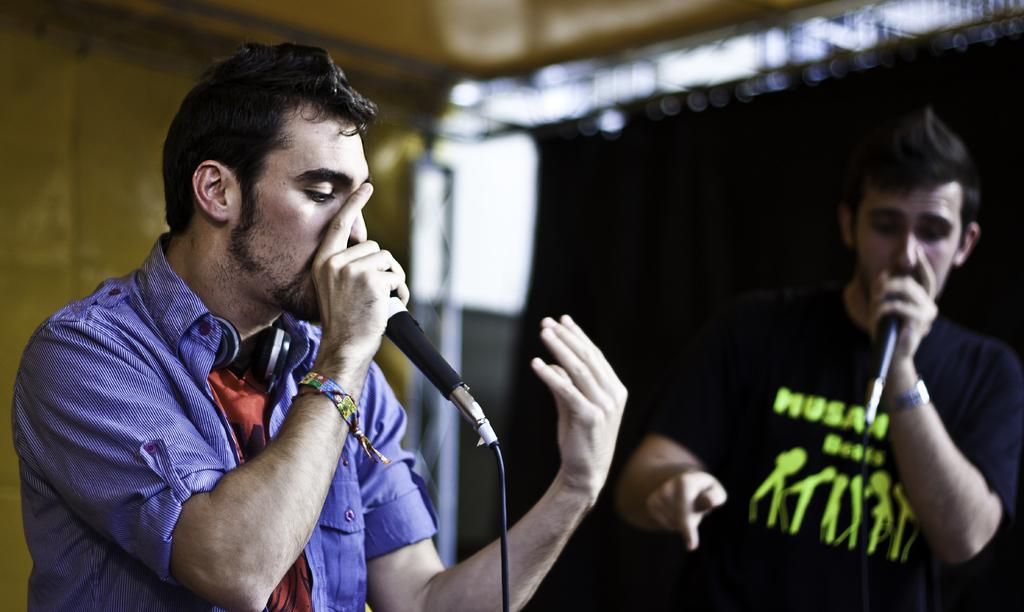How many people are in the image? There are two persons in the image. What are the persons doing in the image? The persons are standing and holding a microphone. What is the color of the cloth in the background of the image? There is a black cloth in the background of the image. What is one of the persons doing with the microphone? One of the persons is singing. What type of lettuce can be seen in the image? There is no lettuce present in the image. How many parcels are being delivered in the image? There is no parcel delivery depicted in the image. 